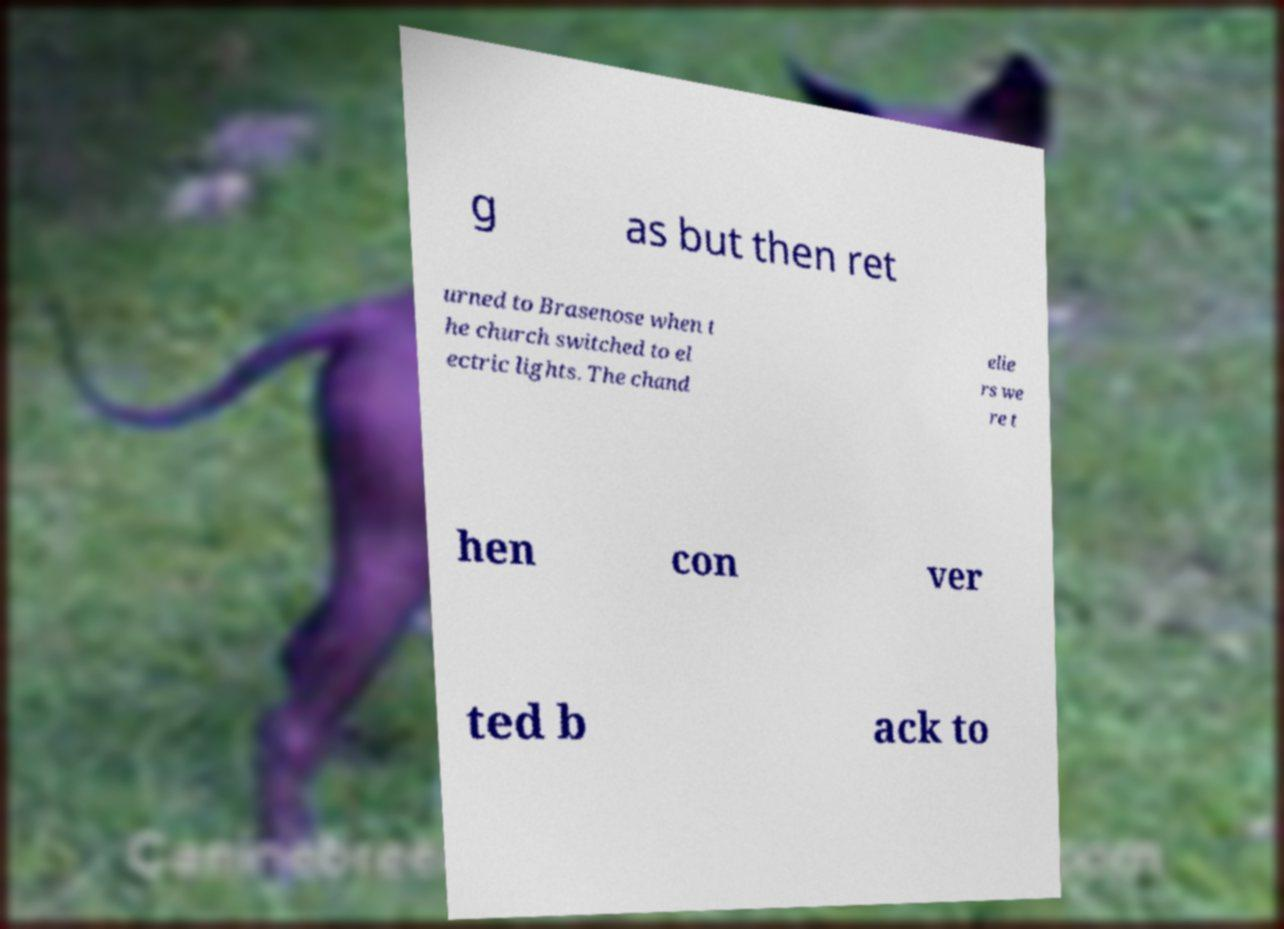Please identify and transcribe the text found in this image. g as but then ret urned to Brasenose when t he church switched to el ectric lights. The chand elie rs we re t hen con ver ted b ack to 